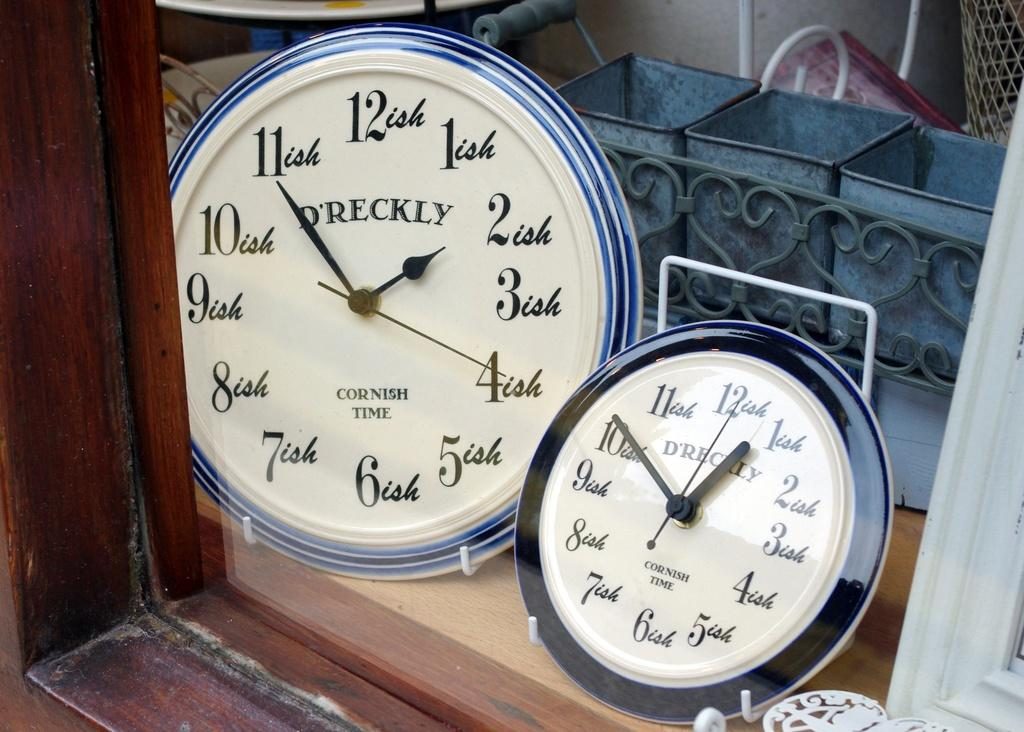<image>
Present a compact description of the photo's key features. the number 12 that is on a clock 